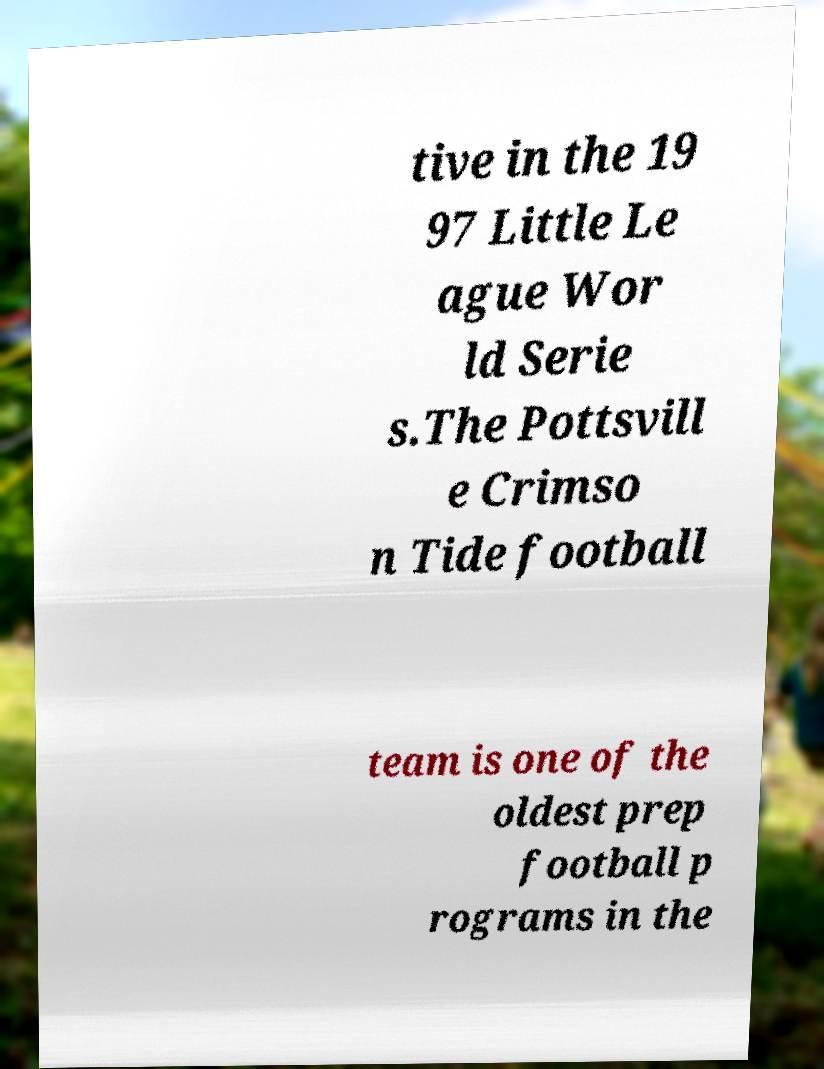What messages or text are displayed in this image? I need them in a readable, typed format. tive in the 19 97 Little Le ague Wor ld Serie s.The Pottsvill e Crimso n Tide football team is one of the oldest prep football p rograms in the 